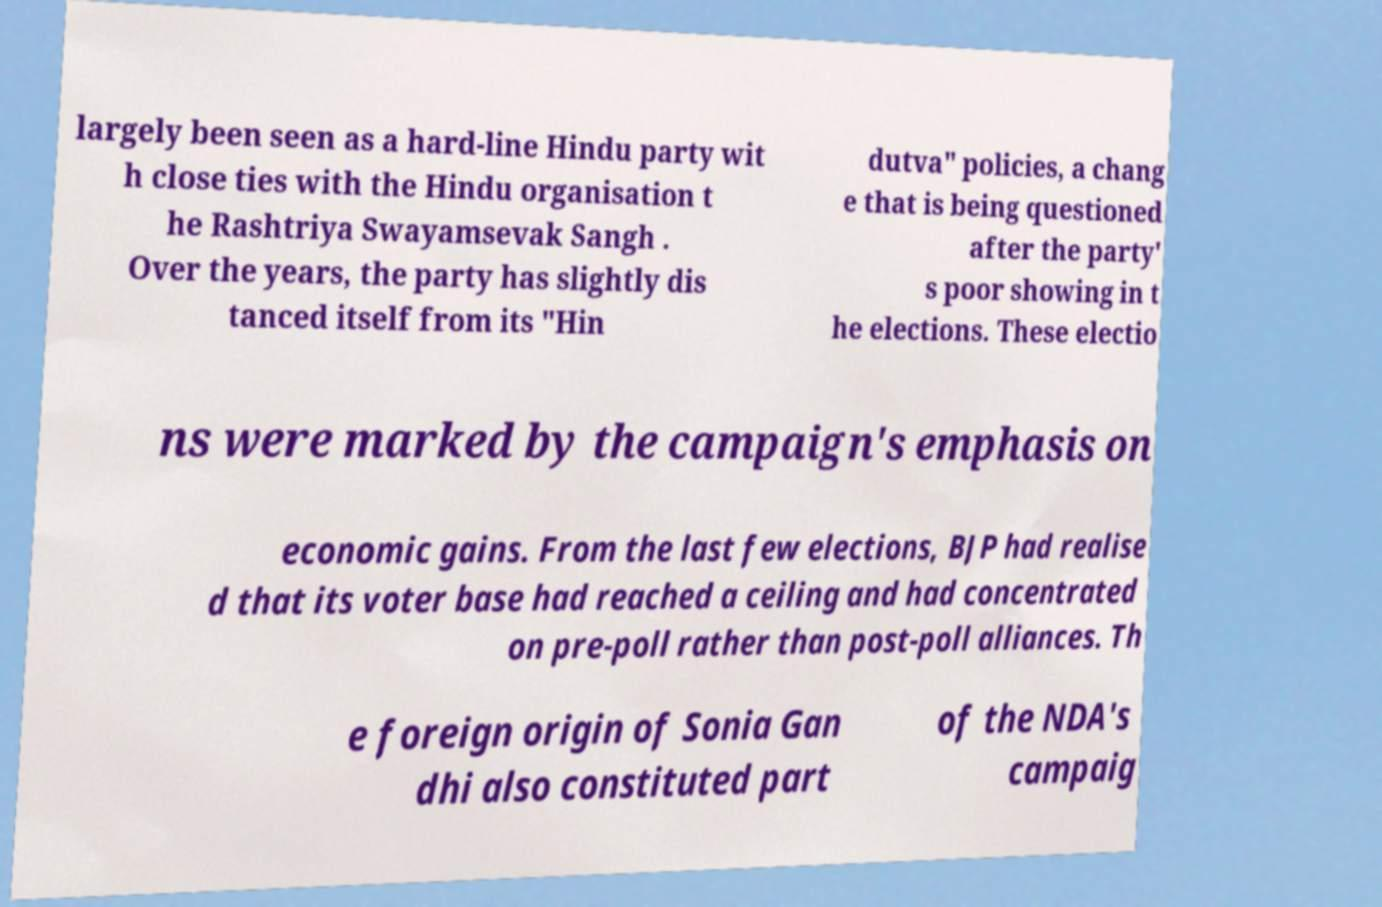Please read and relay the text visible in this image. What does it say? largely been seen as a hard-line Hindu party wit h close ties with the Hindu organisation t he Rashtriya Swayamsevak Sangh . Over the years, the party has slightly dis tanced itself from its "Hin dutva" policies, a chang e that is being questioned after the party' s poor showing in t he elections. These electio ns were marked by the campaign's emphasis on economic gains. From the last few elections, BJP had realise d that its voter base had reached a ceiling and had concentrated on pre-poll rather than post-poll alliances. Th e foreign origin of Sonia Gan dhi also constituted part of the NDA's campaig 